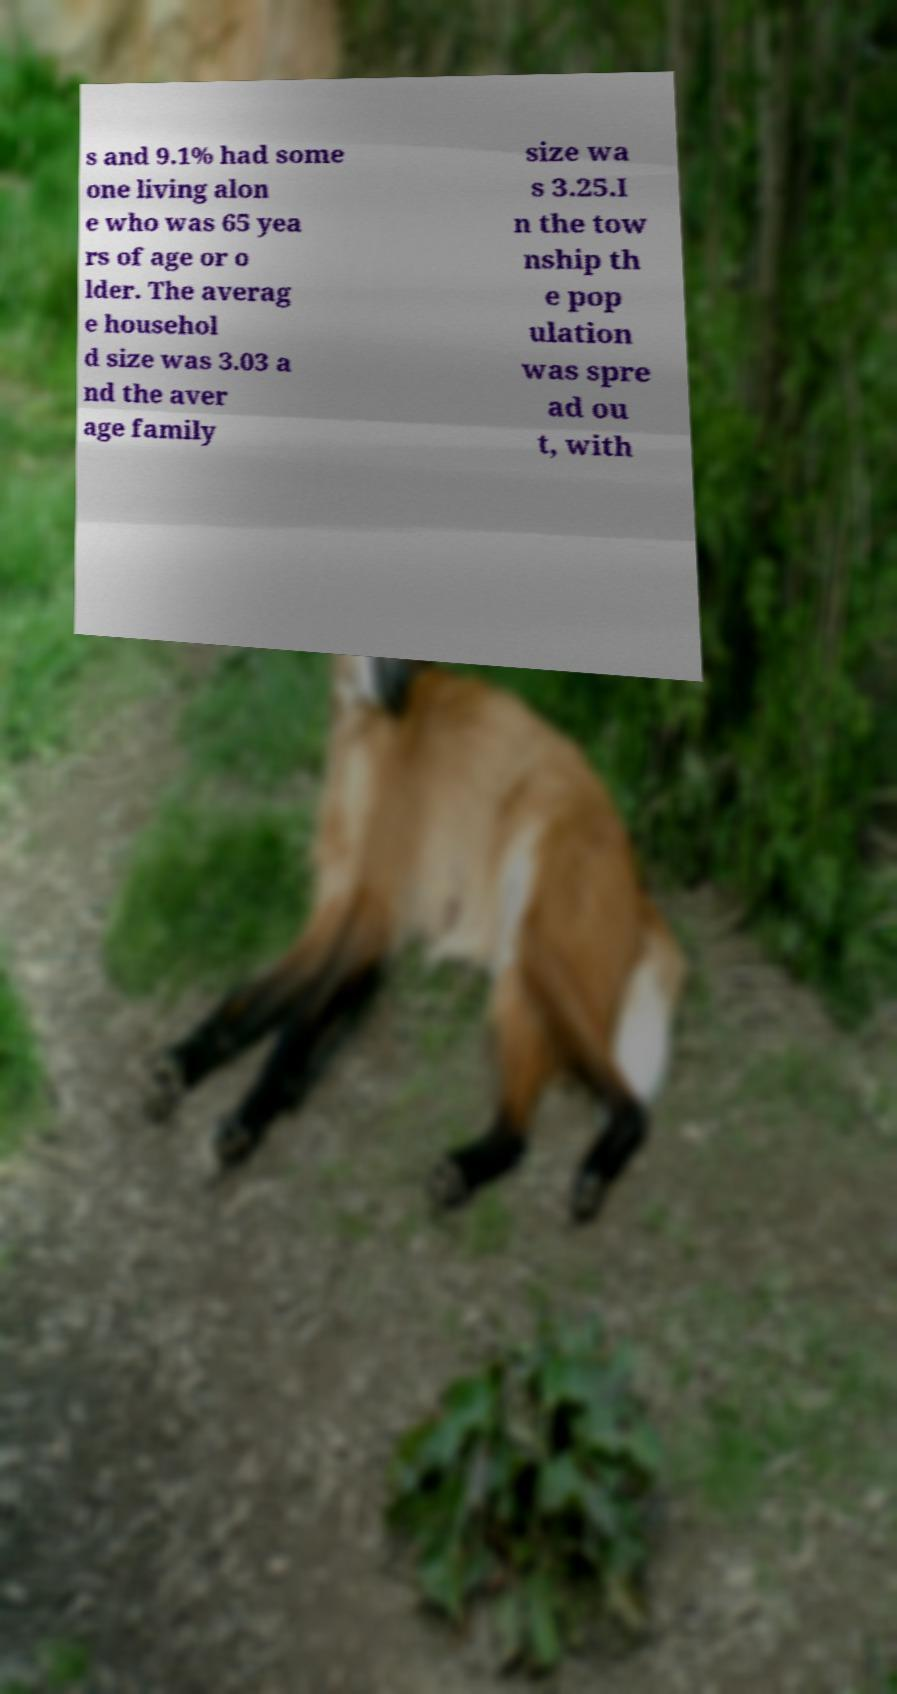There's text embedded in this image that I need extracted. Can you transcribe it verbatim? s and 9.1% had some one living alon e who was 65 yea rs of age or o lder. The averag e househol d size was 3.03 a nd the aver age family size wa s 3.25.I n the tow nship th e pop ulation was spre ad ou t, with 